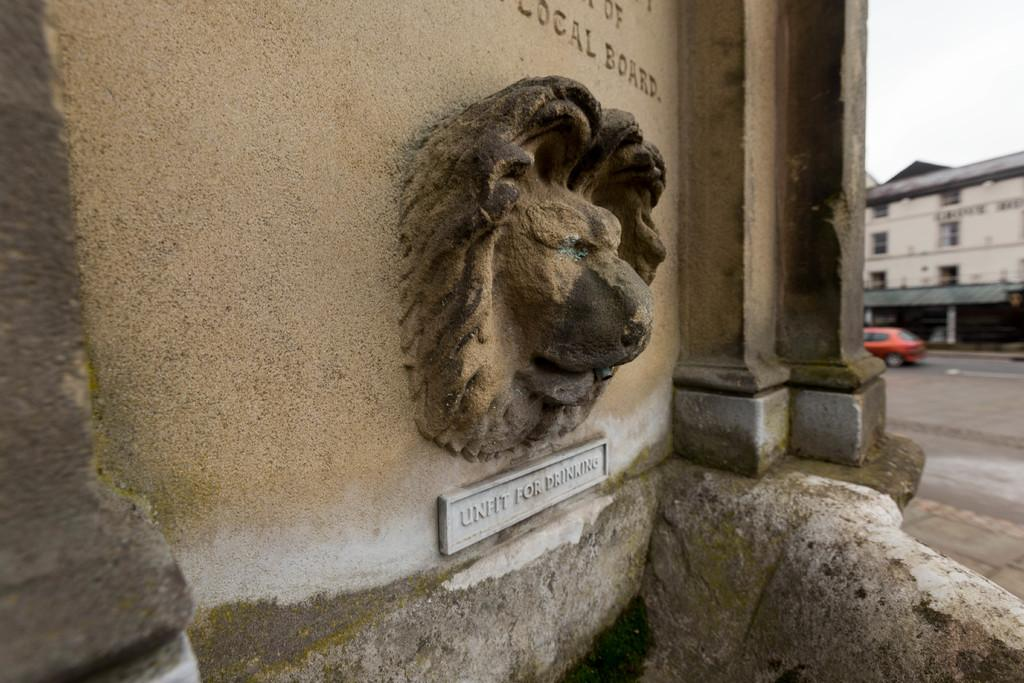What is the main subject in the image? There is a sculpture in the image. What else can be seen on the wall in the image? There is writing on a wall in the image. What structure is located on the right side of the image? There is a building on the right side of the image. What type of transportation is visible on the road in the image? There is a vehicle on the road in the image. What part of the natural environment is visible in the image? The sky is visible in the image. What year was the secretary appointed in the image? There is no secretary present in the image, so it is not possible to determine the year of any appointment. 